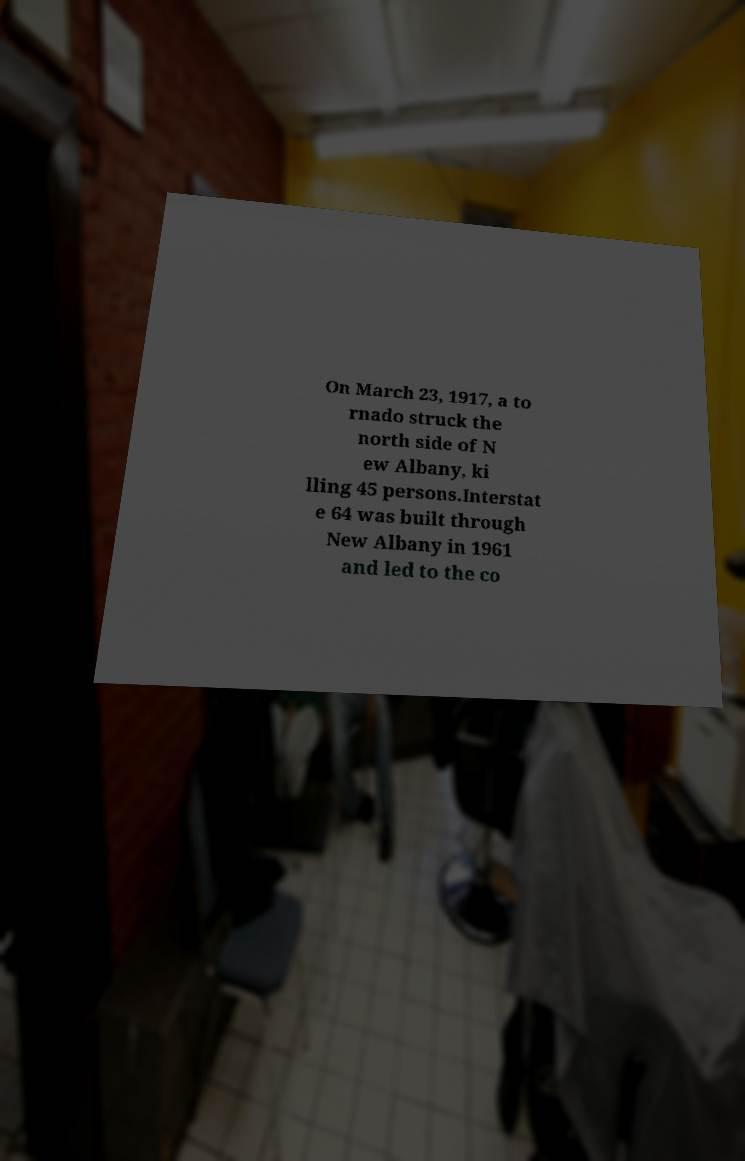Could you assist in decoding the text presented in this image and type it out clearly? On March 23, 1917, a to rnado struck the north side of N ew Albany, ki lling 45 persons.Interstat e 64 was built through New Albany in 1961 and led to the co 